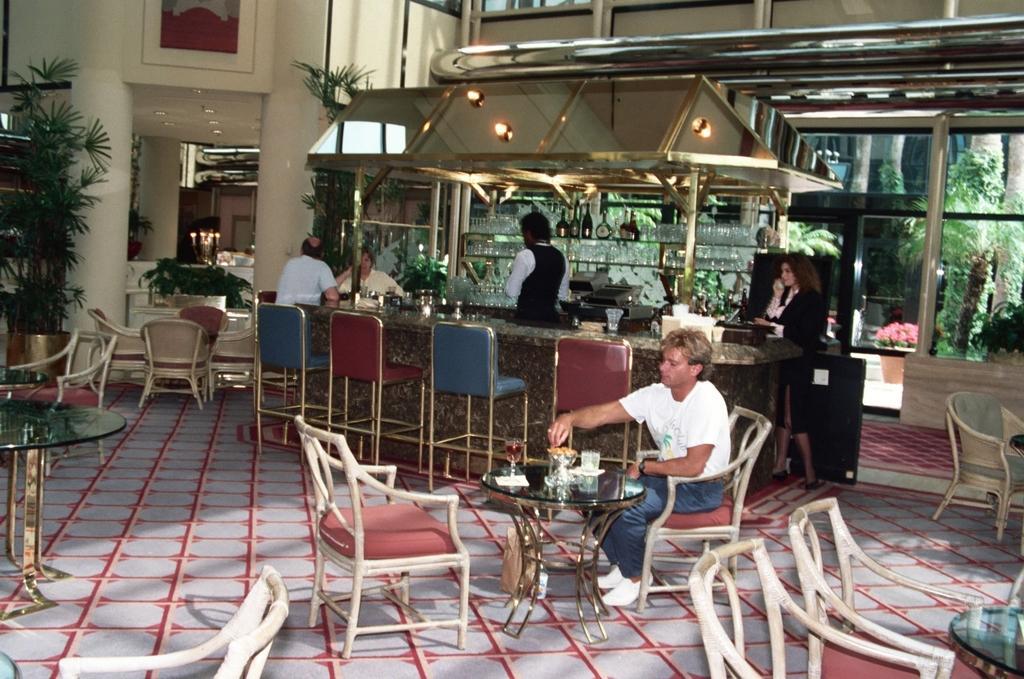Can you describe this image briefly? This person is sitting on a chair. In-front of this person there is a table, on a table there is a glass. Far this person is standing. This woman is also standing. This is a rack with bottles and glasses. These are plants. Outside of this glass door there are trees and plants with flowers. Far there are candles with fire. 